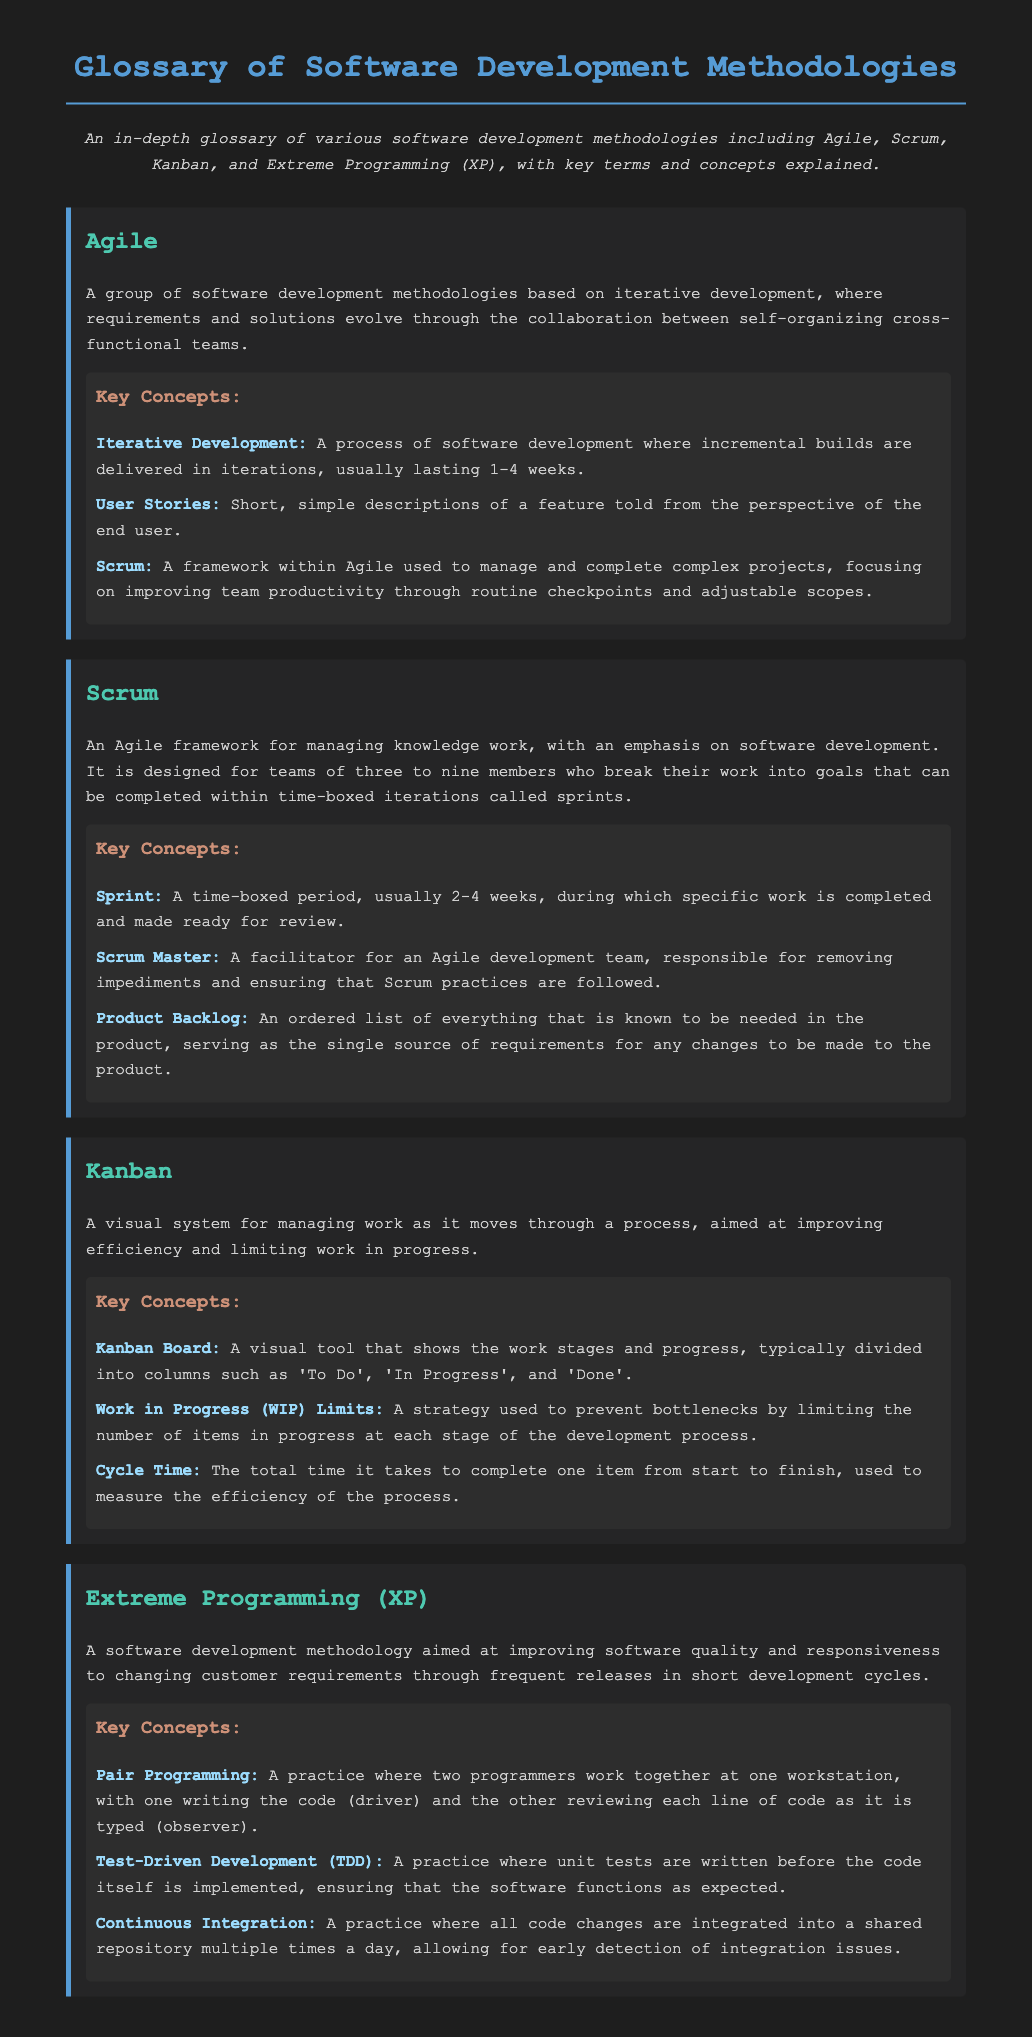What is Agile? Agile is defined as a group of software development methodologies based on iterative development, where requirements and solutions evolve through the collaboration between self-organizing cross-functional teams.
Answer: A group of software development methodologies What is a Sprint? A Sprint is a time-boxed period, usually 2-4 weeks, during which specific work is completed and made ready for review.
Answer: 2-4 weeks What does the term Kanban Board refer to? A Kanban Board is a visual tool that shows the work stages and progress, typically divided into columns such as 'To Do', 'In Progress', and 'Done'.
Answer: A visual tool What is Pair Programming? Pair Programming is a practice where two programmers work together at one workstation, with one writing the code and the other reviewing each line of code as it is typed.
Answer: A practice where two programmers work together How does Test-Driven Development (TDD) work? TDD is a practice where unit tests are written before the code itself is implemented, ensuring that the software functions as expected.
Answer: Unit tests are written before the code What is the main focus of Extreme Programming (XP)? The main focus of XP is improving software quality and responsiveness to changing customer requirements through frequent releases in short development cycles.
Answer: Improving software quality What does Work in Progress (WIP) Limits aim to prevent? WIP Limits is aimed at preventing bottlenecks by limiting the number of items in progress at each stage of the development process.
Answer: Preventing bottlenecks What role does the Scrum Master play? The Scrum Master is a facilitator for an Agile development team, responsible for removing impediments and ensuring that Scrum practices are followed.
Answer: A facilitator for an Agile development team 